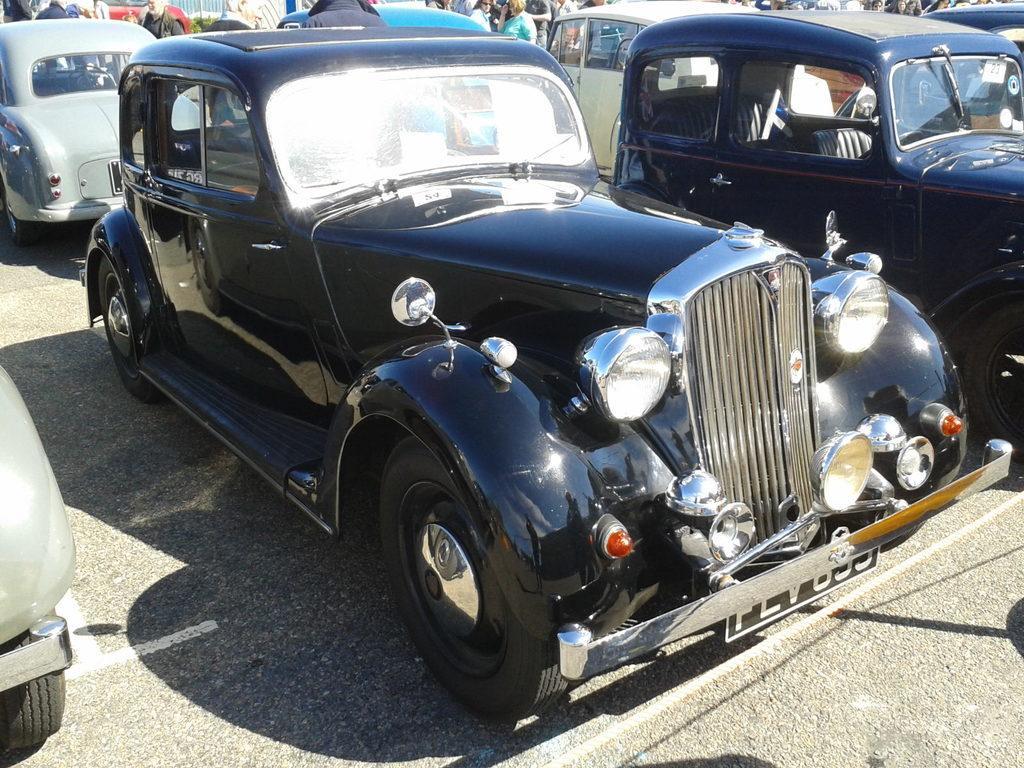Please provide a concise description of this image. In this picture there are vehicles on the road. At the back there are group of people and there is a plant. In the foreground there is a rope. At the bottom there is a road. 